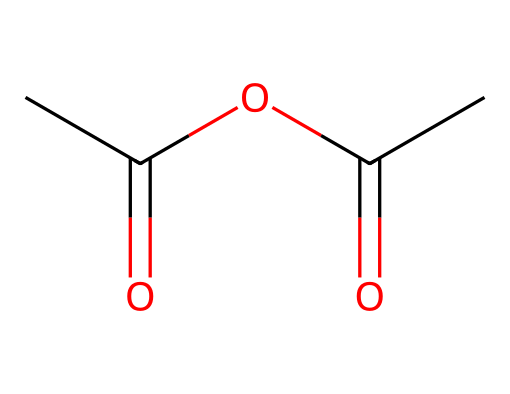What is the molecular formula of acetic anhydride? The SMILES representation indicates that the compound contains two acetyl groups (CC(=O)) connected by an oxygen atom (O). Counting the atoms gives C4, H6, and O3. Therefore, the molecular formula is derived from the individual atoms present in the structure.
Answer: C4H6O3 How many carbon atoms are present in this molecule? In the provided SMILES, the structure shows that there are four carbon (C) atoms. By counting the occurrences of 'C', we can ascertain the total number.
Answer: 4 What type of chemical is acetic anhydride classified as? Given that the structure shows two acyl groups bonded through oxygen, it fits the definition of an acid anhydride, specifically derived from acetic acid. This classification is determined by recognizing the functional groups present in the molecular structure.
Answer: acid anhydride What is the degree of unsaturation of acetic anhydride? The degree of unsaturation can be calculated from the formula: (2C + 2 + N - H - X) / 2. Using the molecular formula (C4H6O3), we find that it has two degrees of unsaturation based on the presence of double bonds in the carbonyl groups and the ring structure formed in anhydrides.
Answer: 2 Which part of the molecule indicates the presence of an anhydride functional group? The connection between the two acyl groups through oxygen (O) signifies the anhydride functional group, as observed in the structure where both acyl groups have a carbonyl (C=O) linkage to the oxygen. This is a defining feature of anhydrides, visually identifiable in the SMILES.
Answer: oxygen linkage 